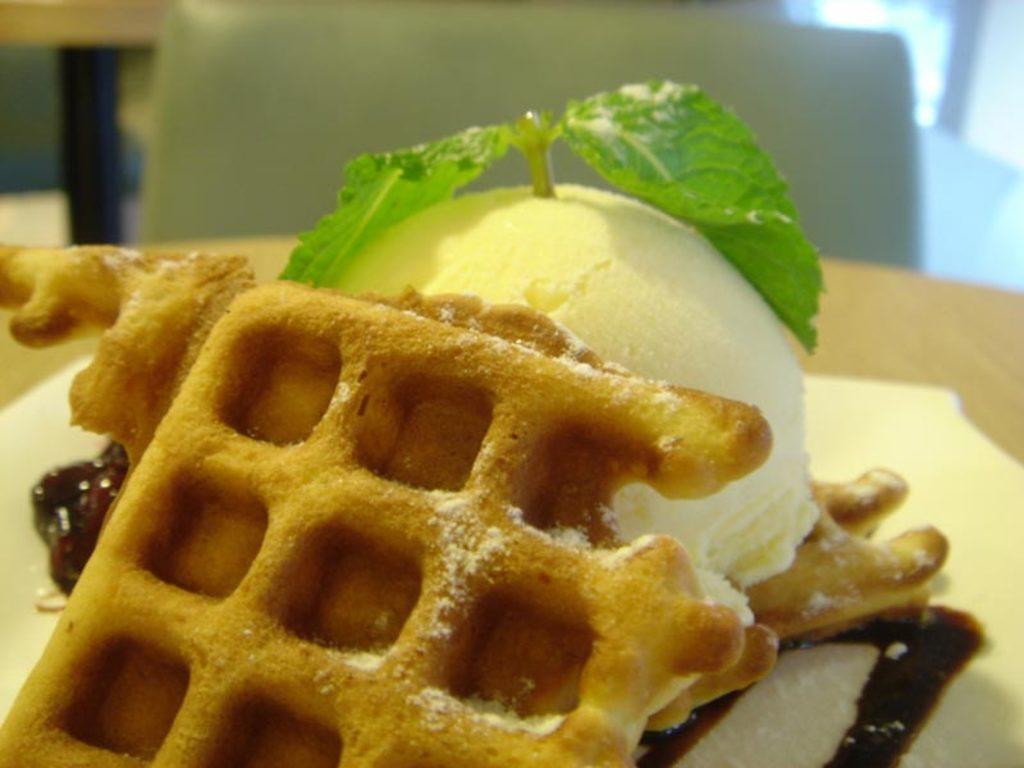Can you describe this image briefly? We can see ice cream,vegetable leaves and food on the table and we can see chair. 